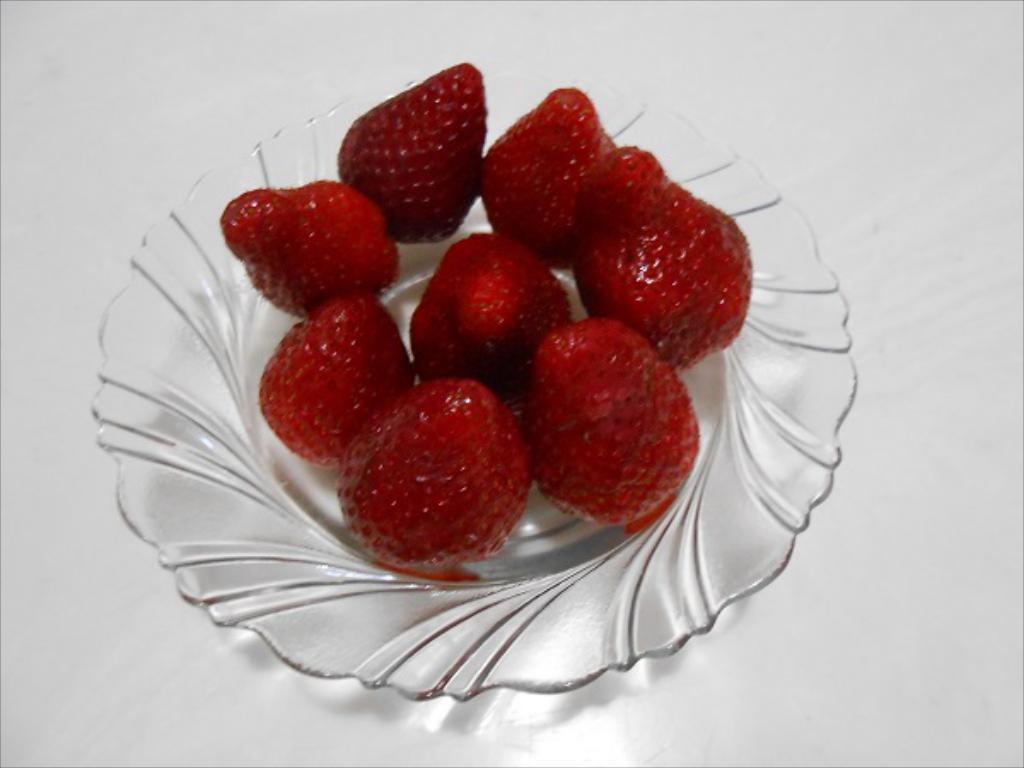In one or two sentences, can you explain what this image depicts? In this image I can see a glass bowl on the white colored surface. In the bowl I can see few strawberries which are red in color. 